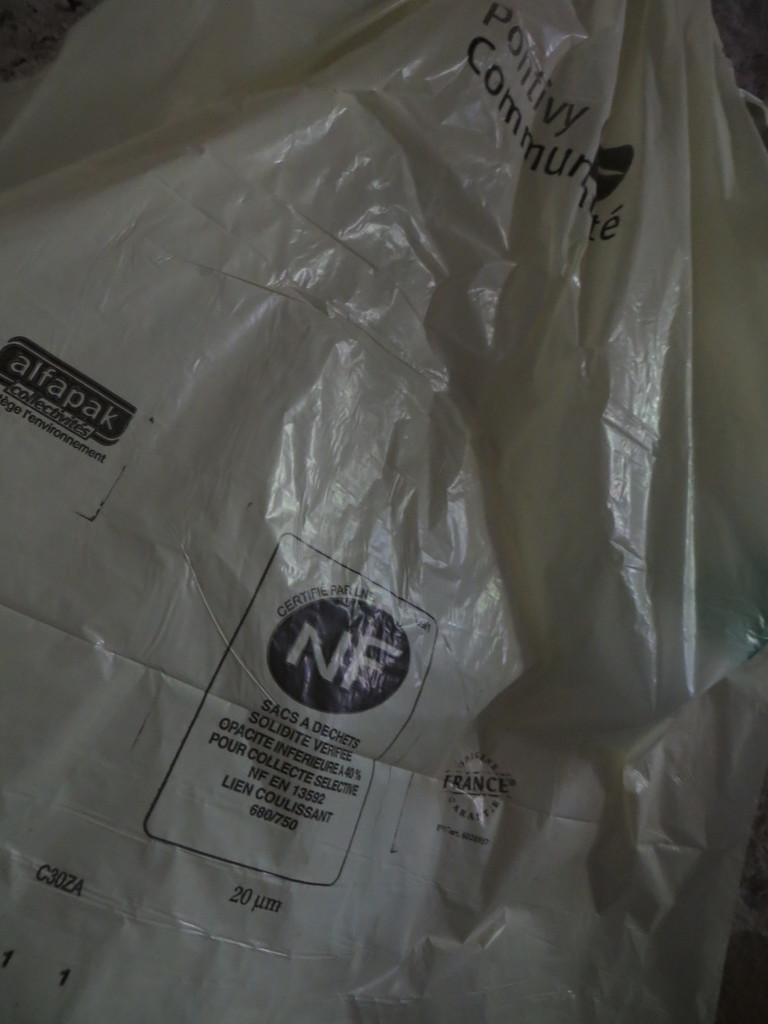What is present in the image that has a cover? There is a cover in the image. What can be found on the cover? The cover has text on it. Who is the representative of the thing in the image? There is no representative or thing mentioned in the image; it only features a cover with text on it. 